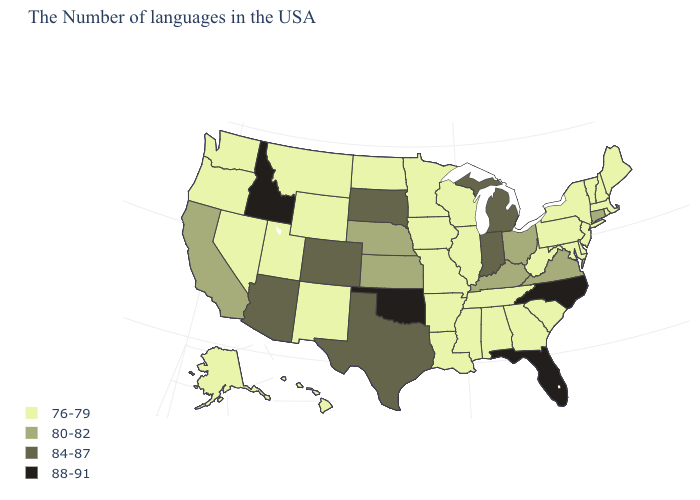What is the lowest value in states that border North Dakota?
Write a very short answer. 76-79. Does New Hampshire have a lower value than Wisconsin?
Write a very short answer. No. Name the states that have a value in the range 76-79?
Keep it brief. Maine, Massachusetts, Rhode Island, New Hampshire, Vermont, New York, New Jersey, Delaware, Maryland, Pennsylvania, South Carolina, West Virginia, Georgia, Alabama, Tennessee, Wisconsin, Illinois, Mississippi, Louisiana, Missouri, Arkansas, Minnesota, Iowa, North Dakota, Wyoming, New Mexico, Utah, Montana, Nevada, Washington, Oregon, Alaska, Hawaii. Does the map have missing data?
Concise answer only. No. Does Colorado have the same value as Michigan?
Write a very short answer. Yes. Name the states that have a value in the range 76-79?
Be succinct. Maine, Massachusetts, Rhode Island, New Hampshire, Vermont, New York, New Jersey, Delaware, Maryland, Pennsylvania, South Carolina, West Virginia, Georgia, Alabama, Tennessee, Wisconsin, Illinois, Mississippi, Louisiana, Missouri, Arkansas, Minnesota, Iowa, North Dakota, Wyoming, New Mexico, Utah, Montana, Nevada, Washington, Oregon, Alaska, Hawaii. Does Arkansas have a lower value than North Carolina?
Give a very brief answer. Yes. What is the highest value in states that border Colorado?
Answer briefly. 88-91. Name the states that have a value in the range 84-87?
Answer briefly. Michigan, Indiana, Texas, South Dakota, Colorado, Arizona. How many symbols are there in the legend?
Concise answer only. 4. Does Oregon have the lowest value in the USA?
Give a very brief answer. Yes. Which states have the highest value in the USA?
Answer briefly. North Carolina, Florida, Oklahoma, Idaho. What is the value of Colorado?
Write a very short answer. 84-87. Does Florida have the highest value in the USA?
Be succinct. Yes. 